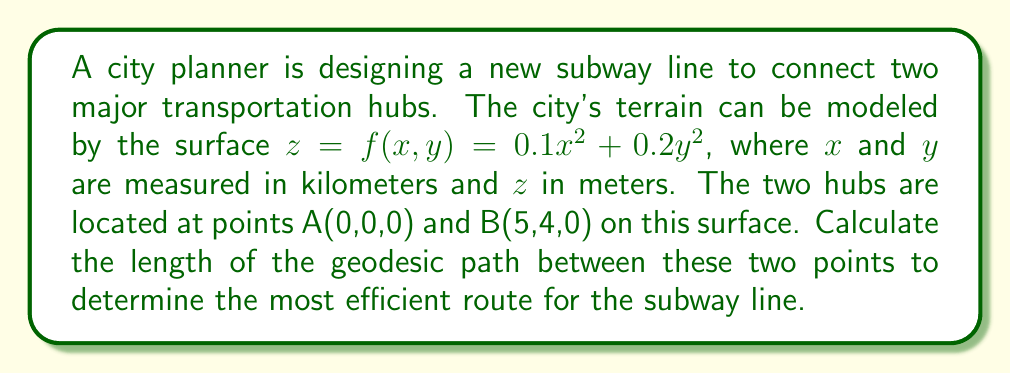Show me your answer to this math problem. To solve this problem, we'll follow these steps:

1) The geodesic on a surface is the shortest path between two points on that surface. For a general surface $z = f(x,y)$, the length of a geodesic path is given by:

   $$L = \int_0^1 \sqrt{E\dot{x}^2 + 2F\dot{x}\dot{y} + G\dot{y}^2} dt$$

   where $E = 1 + f_x^2$, $F = f_xf_y$, and $G = 1 + f_y^2$

2) For our surface $z = 0.1x^2 + 0.2y^2$:
   
   $f_x = 0.2x$, $f_y = 0.4y$
   
   $E = 1 + (0.2x)^2 = 1 + 0.04x^2$
   $F = (0.2x)(0.4y) = 0.08xy$
   $G = 1 + (0.4y)^2 = 1 + 0.16y^2$

3) The straight line path between A and B is:
   
   $x(t) = 5t$, $y(t) = 4t$, $0 \leq t \leq 1$
   
   $\dot{x} = 5$, $\dot{y} = 4$

4) Substituting into the integral:

   $$L = \int_0^1 \sqrt{(1 + 0.04(5t)^2)(5)^2 + 2(0.08(5t)(4t))(5)(4) + (1 + 0.16(4t)^2)(4)^2} dt$$

5) Simplifying:

   $$L = \int_0^1 \sqrt{25 + 5t^2 + 32 + 10.24t^2 + 16 + 10.24t^2} dt$$
   $$L = \int_0^1 \sqrt{73 + 25.48t^2} dt$$

6) This integral doesn't have a simple analytical solution. We need to use numerical integration methods to evaluate it. Using a computer algebra system or numerical integration tool, we find:

   $$L \approx 6.6328 \text{ km}$$
Answer: 6.6328 km 